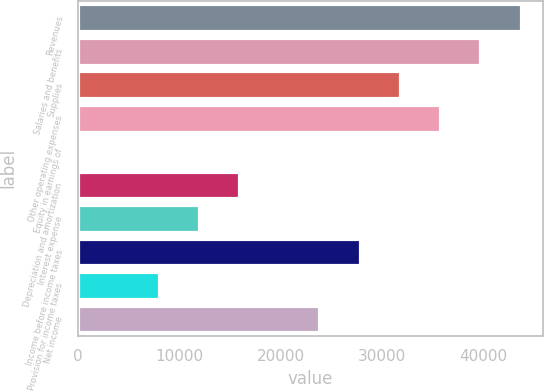Convert chart. <chart><loc_0><loc_0><loc_500><loc_500><bar_chart><fcel>Revenues<fcel>Salaries and benefits<fcel>Supplies<fcel>Other operating expenses<fcel>Equity in earnings of<fcel>Depreciation and amortization<fcel>Interest expense<fcel>Income before income taxes<fcel>Provision for income taxes<fcel>Net income<nl><fcel>43641.2<fcel>39678<fcel>31751.6<fcel>35714.8<fcel>46<fcel>15898.8<fcel>11935.6<fcel>27788.4<fcel>7972.4<fcel>23825.2<nl></chart> 